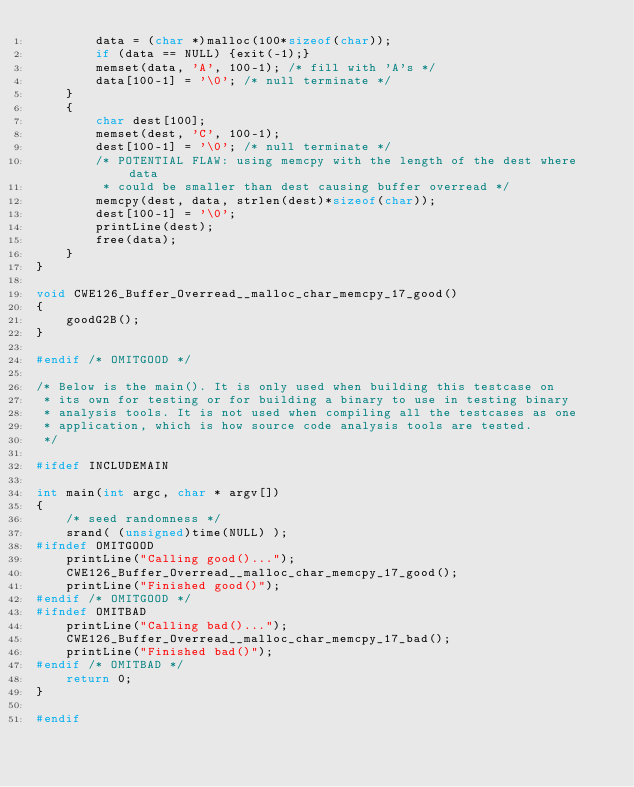Convert code to text. <code><loc_0><loc_0><loc_500><loc_500><_C_>        data = (char *)malloc(100*sizeof(char));
        if (data == NULL) {exit(-1);}
        memset(data, 'A', 100-1); /* fill with 'A's */
        data[100-1] = '\0'; /* null terminate */
    }
    {
        char dest[100];
        memset(dest, 'C', 100-1);
        dest[100-1] = '\0'; /* null terminate */
        /* POTENTIAL FLAW: using memcpy with the length of the dest where data
         * could be smaller than dest causing buffer overread */
        memcpy(dest, data, strlen(dest)*sizeof(char));
        dest[100-1] = '\0';
        printLine(dest);
        free(data);
    }
}

void CWE126_Buffer_Overread__malloc_char_memcpy_17_good()
{
    goodG2B();
}

#endif /* OMITGOOD */

/* Below is the main(). It is only used when building this testcase on
 * its own for testing or for building a binary to use in testing binary
 * analysis tools. It is not used when compiling all the testcases as one
 * application, which is how source code analysis tools are tested.
 */

#ifdef INCLUDEMAIN

int main(int argc, char * argv[])
{
    /* seed randomness */
    srand( (unsigned)time(NULL) );
#ifndef OMITGOOD
    printLine("Calling good()...");
    CWE126_Buffer_Overread__malloc_char_memcpy_17_good();
    printLine("Finished good()");
#endif /* OMITGOOD */
#ifndef OMITBAD
    printLine("Calling bad()...");
    CWE126_Buffer_Overread__malloc_char_memcpy_17_bad();
    printLine("Finished bad()");
#endif /* OMITBAD */
    return 0;
}

#endif
</code> 